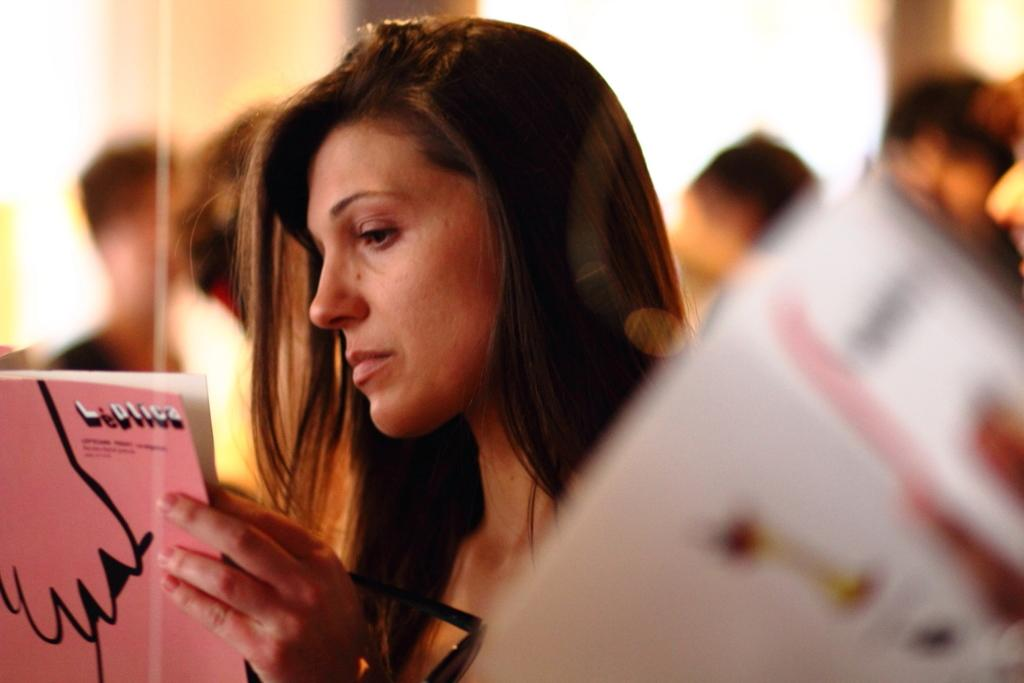Who is present in the image? There is a woman in the image. What is the woman wearing? The woman is wearing clothes. What is the woman holding in her hands? The woman is holding a book and goggles. Can you describe the background of the image? The background of the image is blurred. What type of cup is the woman offering in the image? There is no cup present in the image, and the woman is not offering anything. 